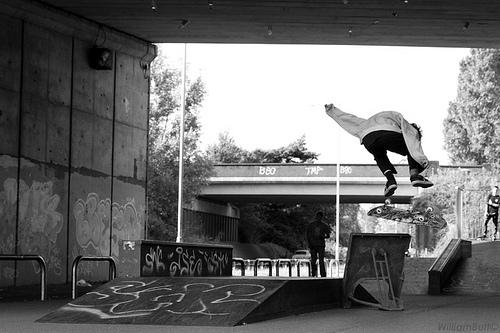Provide a description of the most prominent action taking place in the image. A skateboarder is attempting a trick in mid-air as his skateboard flips wheels-up, while his feet are off the board. Mention the central activity being performed and the individual responsible for it. An airborne skateboarder is skillfully executing a trick above a vibrant graffiti ramp as observers stand nearby. In just a few words, describe the significant happening in the image. Skateboarder performing mid-air trick over graffiti ramp. Mention the primary activity and its main participant in the image. A man in a white sweatshirt and black pants is performing a skateboarding trick mid-air over a graffiti-covered ramp. Describe the scene as it appears in the image, including the main subjects. A male skateboarder is in mid-air over a ramp with graffiti, while another person stands in the shadows and a boy dressed in black waits for his turn. What is the most eye-catching movement in the image and who is doing it? A man in a sweatshirt performs a striking mid-air skateboarding trick as his skateboard flips upside down. Write a summary of the image which highlights the central occurrence. A skateboarder executes a mid-air stunt over a colorful graffiti ramp, as a few bystanders watch the action. Write a short statement summarizing the main action and its protagonist in the image. A male skateboarder is captured mid-air as he performs a thrilling trick above a ramp adorned with bold graffiti. Craft a brief narration which portrays the chief subjects and activity in the image. Focused on a skateboarding trick, a young man soars through the air above a graffiti-laden ramp, as onlookers stand by. Outline the primary event and its characters in the image. A skateboarder, airborne above a graffiti-covered ramp, attempts a trick while other individuals watch and wait their turn. 